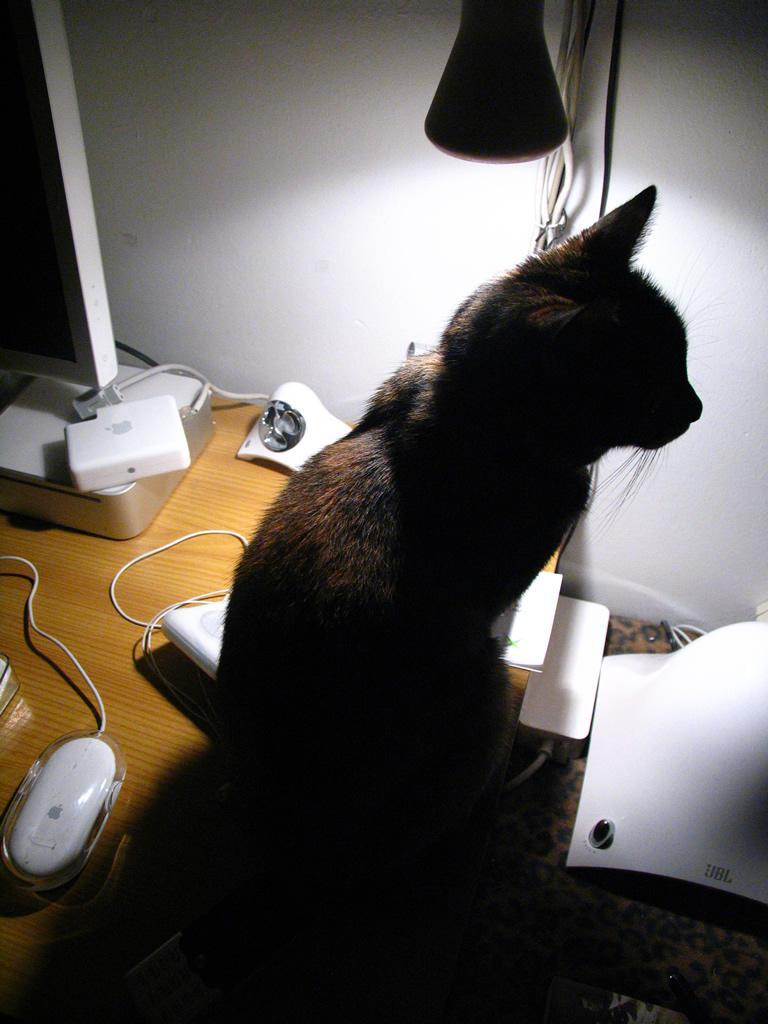What type of animal is in the image? There is a cat in the image. Where is the cat located? The cat is sitting on a wooden table. What other object is on the table with the cat? There is a computer mouse on the table. Are there any other objects on the table? Yes, there are other objects on the table. What type of clover is the cat eating in the image? There is no clover present in the image, and the cat is not eating anything. What book is the cat reading in the image? There is no book present in the image, and the cat is not reading anything. 